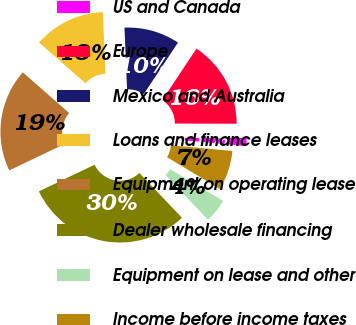Convert chart. <chart><loc_0><loc_0><loc_500><loc_500><pie_chart><fcel>US and Canada<fcel>Europe<fcel>Mexico and Australia<fcel>Loans and finance leases<fcel>Equipment on operating lease<fcel>Dealer wholesale financing<fcel>Equipment on lease and other<fcel>Income before income taxes<nl><fcel>1.43%<fcel>15.71%<fcel>10.0%<fcel>12.86%<fcel>18.57%<fcel>30.0%<fcel>4.29%<fcel>7.14%<nl></chart> 